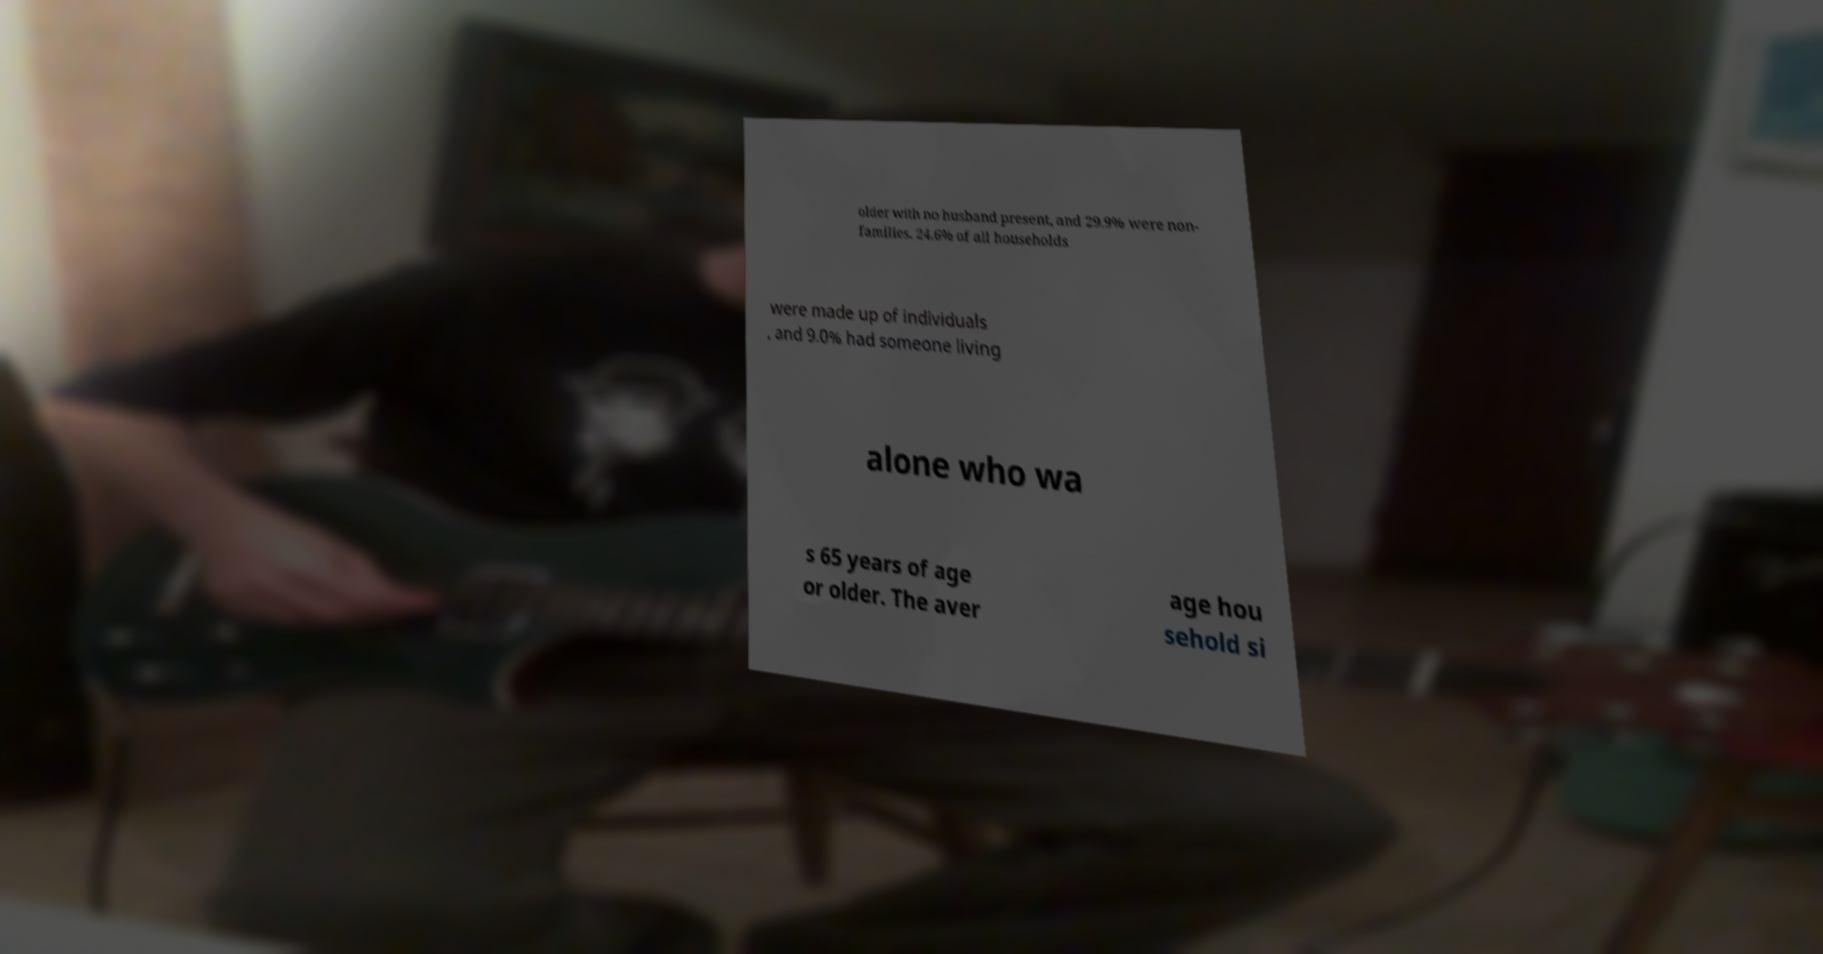I need the written content from this picture converted into text. Can you do that? older with no husband present, and 29.9% were non- families. 24.6% of all households were made up of individuals , and 9.0% had someone living alone who wa s 65 years of age or older. The aver age hou sehold si 